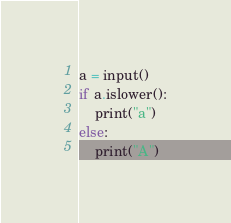Convert code to text. <code><loc_0><loc_0><loc_500><loc_500><_Python_>a = input()
if a.islower():
    print("a")
else:
    print("A")
</code> 